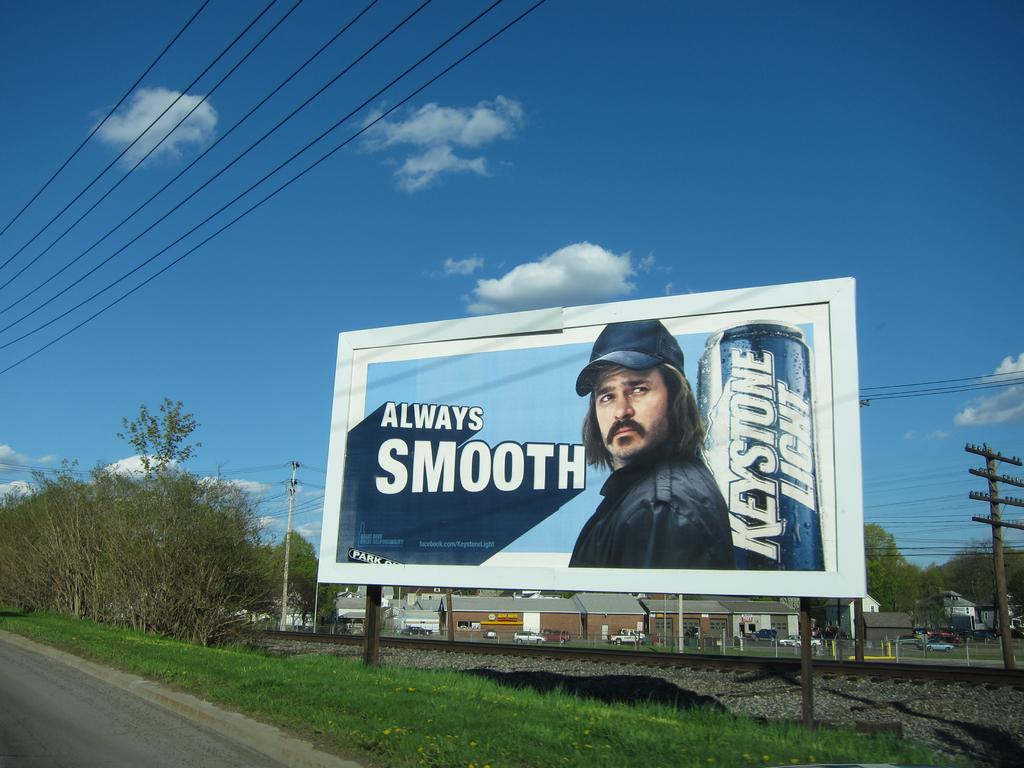<image>
Write a terse but informative summary of the picture. the billboard along the road states that keystone light is always smooth 